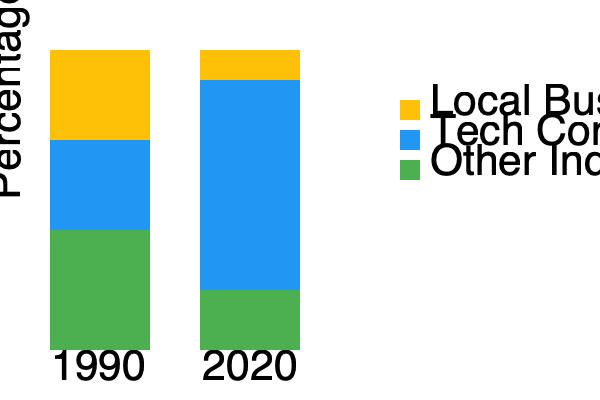Analyze the stacked bar chart depicting the change in local business diversity in Mountain View, California, between 1990 and 2020. Calculate the percentage decrease in local businesses' share of the total business landscape during this period. To calculate the percentage decrease in local businesses' share, we need to follow these steps:

1. Identify the share of local businesses in 1990 and 2020:
   - 1990: Local businesses occupy 90 units out of 300 total units
   - 2020: Local businesses occupy 30 units out of 300 total units

2. Calculate the percentage of local businesses for each year:
   - 1990: $\frac{90}{300} \times 100\% = 30\%$
   - 2020: $\frac{30}{300} \times 100\% = 10\%$

3. Calculate the percentage decrease:
   Percentage decrease = $\frac{\text{Original Value} - \text{New Value}}{\text{Original Value}} \times 100\%$
   
   $= \frac{30\% - 10\%}{30\%} \times 100\%$
   $= \frac{20\%}{30\%} \times 100\%$
   $= 0.6666... \times 100\%$
   $= 66.67\%$

Therefore, the percentage decrease in local businesses' share of the total business landscape between 1990 and 2020 is approximately 66.67%.
Answer: 66.67% 